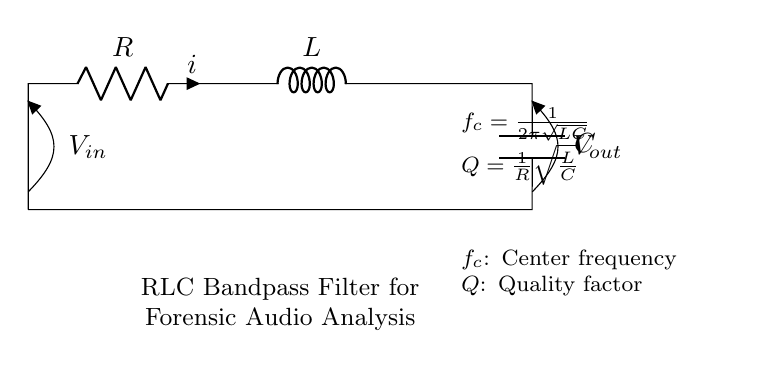What components are in this circuit? The circuit consists of three main components: a resistor, an inductor, and a capacitor. These components are labeled as R, L, and C, respectively.
Answer: Resistor, Inductor, Capacitor What is the relationship between the center frequency and the circuit components? The center frequency is calculated using the formula f_c equals one divided by two pi times the square root of LC. This shows that the center frequency depends on both the inductance (L) and capacitance (C) values in the circuit.
Answer: f_c = 1 / (2π√(LC)) What does the quality factor represent in this RLC circuit? The quality factor (Q) is given by the formula Q equals one divided by R times the square root of L divided by C. It describes the selectivity or sharpness of the bandpass filter, indicating how well the circuit can isolate a specific frequency range.
Answer: Q = 1 / (R√(L/C)) How does increasing the resistance affect the quality factor? Increasing resistance (R) decreases the quality factor (Q) according to the formula Q equals one divided by R times the square root of L divided by C. A lower Q indicates less selectivity, meaning the circuit will allow a wider range of frequencies to pass through instead of isolating a specific frequency.
Answer: Decreases Q What happens to the center frequency if the inductance is doubled? If the inductance (L) is doubled while keeping the capacitance (C) constant, the center frequency (f_c) will decrease because it is inversely proportional to the square root of the inductance in the formula f_c equals one divided by two pi times the square root of LC.
Answer: Decreases f_c What type of filter is represented by this circuit? This circuit is a bandpass filter, meaning it allows a specific range of frequencies to pass while attenuating frequencies outside this range. It isolates particular frequency components important in forensic audio analysis.
Answer: Bandpass filter 